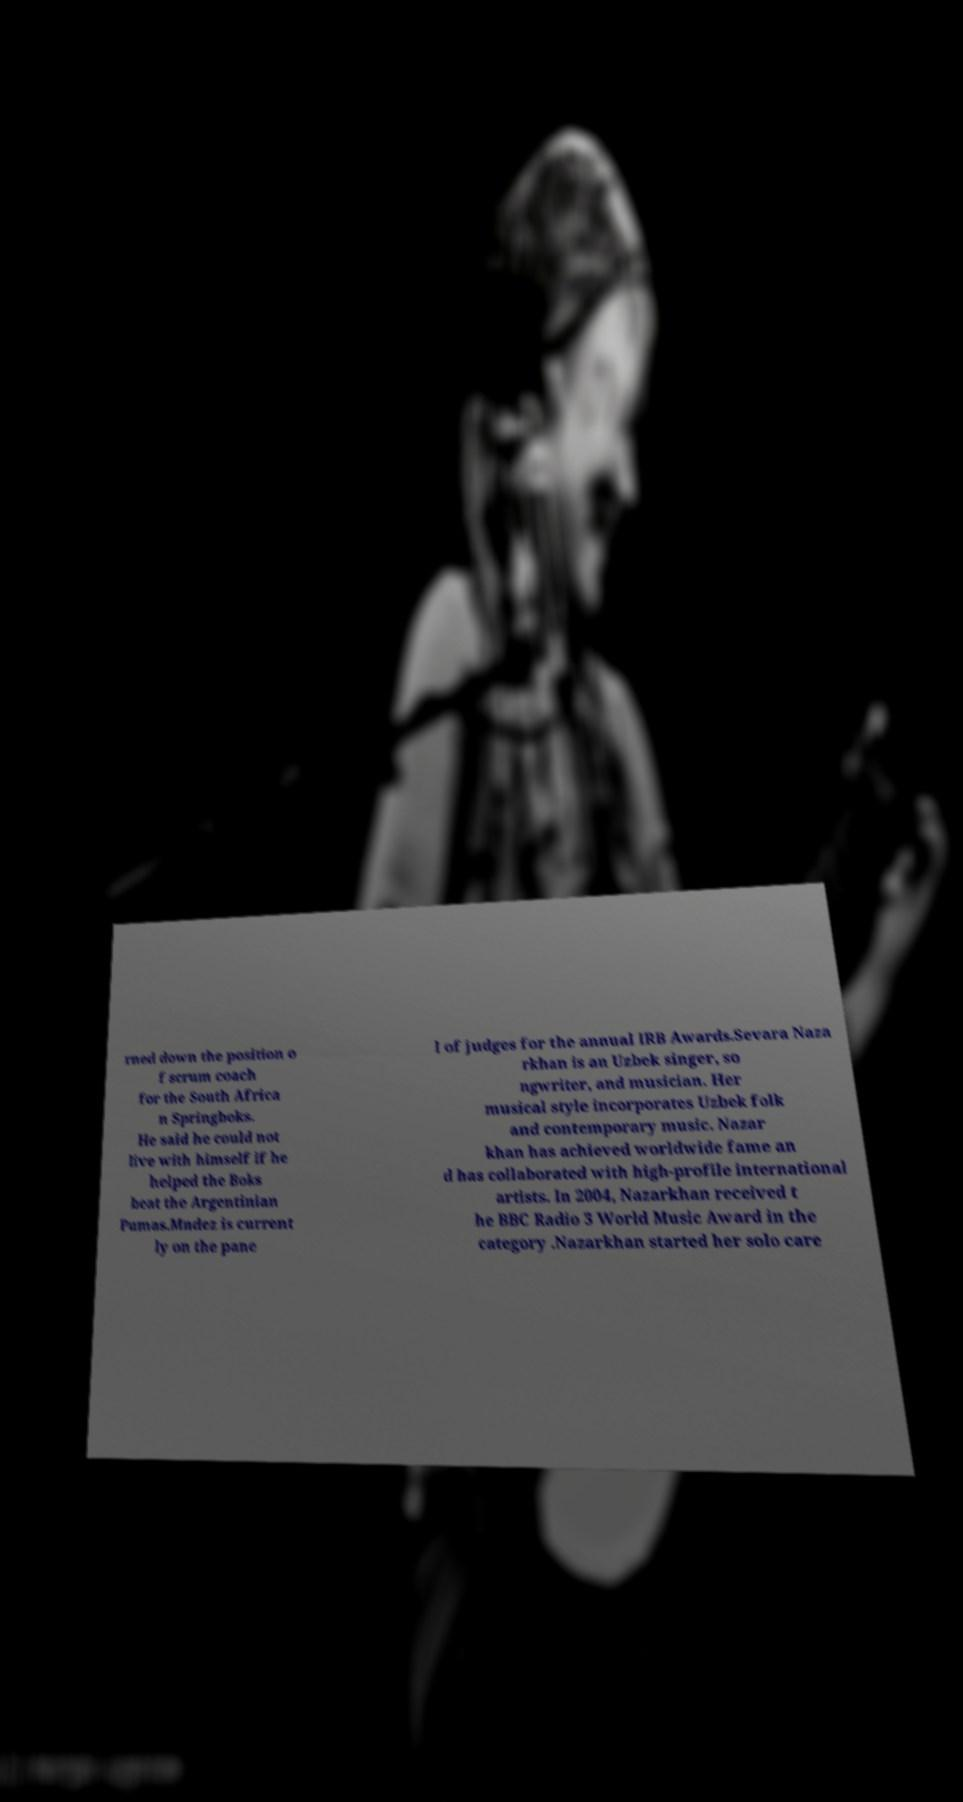Can you read and provide the text displayed in the image?This photo seems to have some interesting text. Can you extract and type it out for me? rned down the position o f scrum coach for the South Africa n Springboks. He said he could not live with himself if he helped the Boks beat the Argentinian Pumas.Mndez is current ly on the pane l of judges for the annual IRB Awards.Sevara Naza rkhan is an Uzbek singer, so ngwriter, and musician. Her musical style incorporates Uzbek folk and contemporary music. Nazar khan has achieved worldwide fame an d has collaborated with high-profile international artists. In 2004, Nazarkhan received t he BBC Radio 3 World Music Award in the category .Nazarkhan started her solo care 